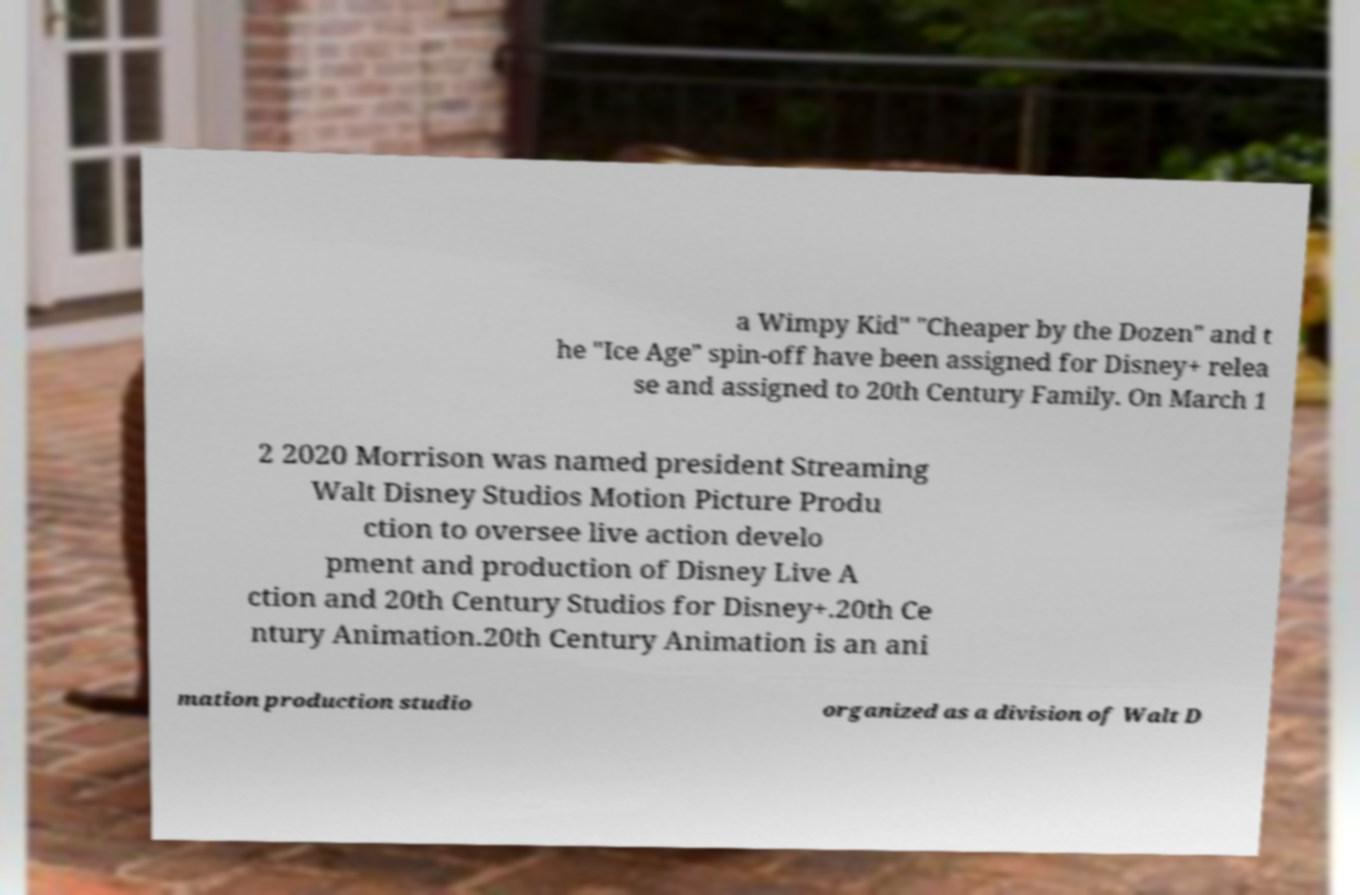Can you read and provide the text displayed in the image?This photo seems to have some interesting text. Can you extract and type it out for me? a Wimpy Kid" "Cheaper by the Dozen" and t he "Ice Age" spin-off have been assigned for Disney+ relea se and assigned to 20th Century Family. On March 1 2 2020 Morrison was named president Streaming Walt Disney Studios Motion Picture Produ ction to oversee live action develo pment and production of Disney Live A ction and 20th Century Studios for Disney+.20th Ce ntury Animation.20th Century Animation is an ani mation production studio organized as a division of Walt D 